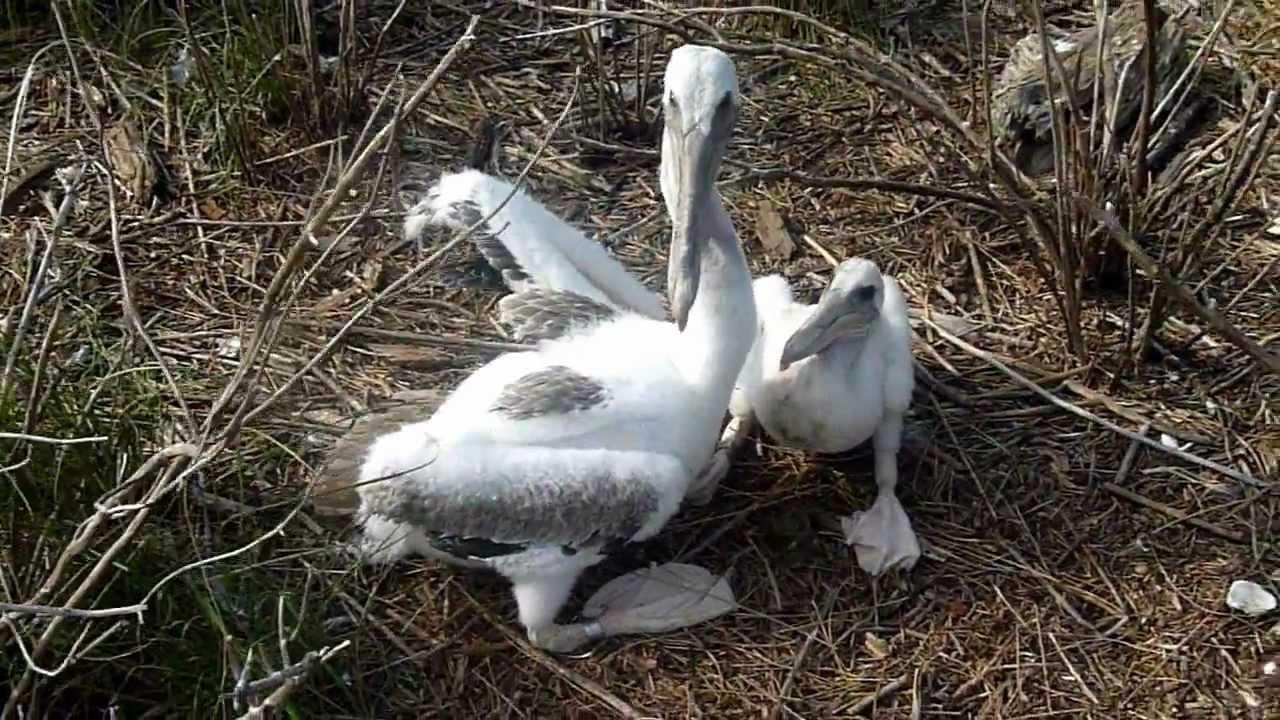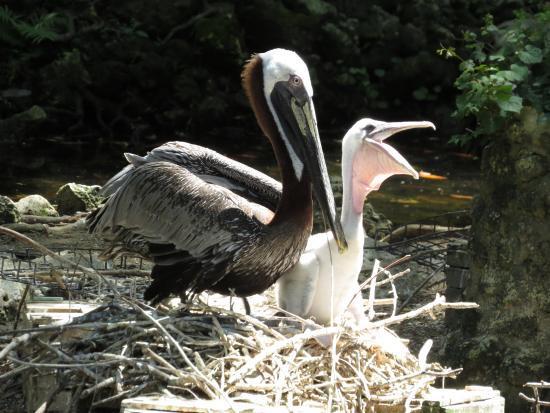The first image is the image on the left, the second image is the image on the right. For the images shown, is this caption "Each image shows exactly two pelicans posed close together." true? Answer yes or no. Yes. The first image is the image on the left, the second image is the image on the right. Evaluate the accuracy of this statement regarding the images: "There are exactly four birds.". Is it true? Answer yes or no. Yes. 